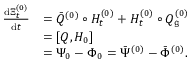<formula> <loc_0><loc_0><loc_500><loc_500>\begin{array} { r l } { \frac { d \Xi _ { t } ^ { ( 0 ) } } { d t } } & { = \ B a r { Q } ^ { ( 0 ) } \circ H _ { t } ^ { ( 0 ) } + H _ { t } ^ { ( 0 ) } \circ Q _ { \mathfrak g } ^ { ( 0 ) } } \\ & { = [ Q , H _ { 0 } ] } \\ & { = \Psi _ { 0 } - \Phi _ { 0 } = \ B a r { \Psi } ^ { ( 0 ) } - \ B a r { \Phi } ^ { ( 0 ) } . } \end{array}</formula> 